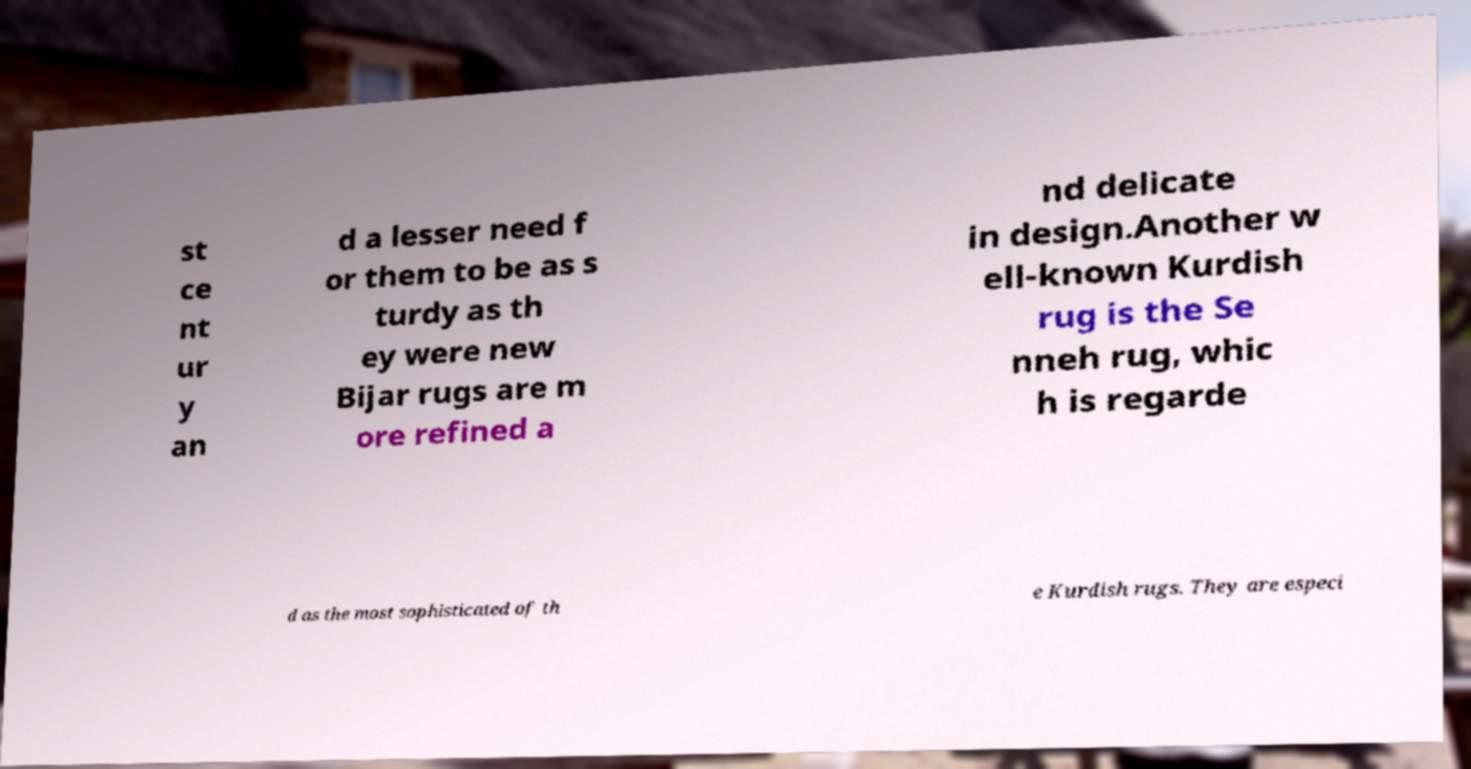Can you accurately transcribe the text from the provided image for me? st ce nt ur y an d a lesser need f or them to be as s turdy as th ey were new Bijar rugs are m ore refined a nd delicate in design.Another w ell-known Kurdish rug is the Se nneh rug, whic h is regarde d as the most sophisticated of th e Kurdish rugs. They are especi 